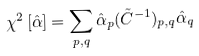<formula> <loc_0><loc_0><loc_500><loc_500>\chi ^ { 2 } \left [ { \hat { \alpha } } \right ] = \sum _ { p , q } \hat { \alpha } _ { p } ( { \tilde { C } ^ { - 1 } } ) _ { p , q } \hat { \alpha } _ { q }</formula> 